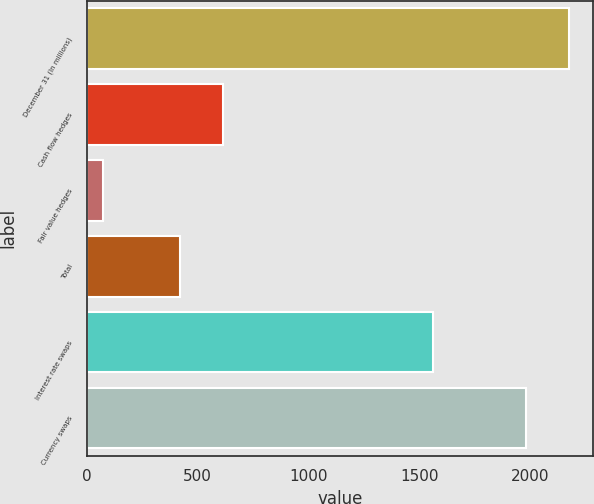Convert chart to OTSL. <chart><loc_0><loc_0><loc_500><loc_500><bar_chart><fcel>December 31 (In millions)<fcel>Cash flow hedges<fcel>Fair value hedges<fcel>Total<fcel>Interest rate swaps<fcel>Currency swaps<nl><fcel>2174.2<fcel>615.2<fcel>75<fcel>422<fcel>1559<fcel>1981<nl></chart> 